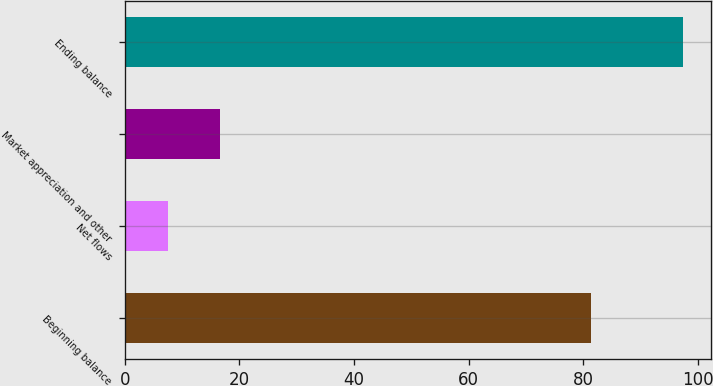<chart> <loc_0><loc_0><loc_500><loc_500><bar_chart><fcel>Beginning balance<fcel>Net flows<fcel>Market appreciation and other<fcel>Ending balance<nl><fcel>81.3<fcel>7.6<fcel>16.59<fcel>97.5<nl></chart> 